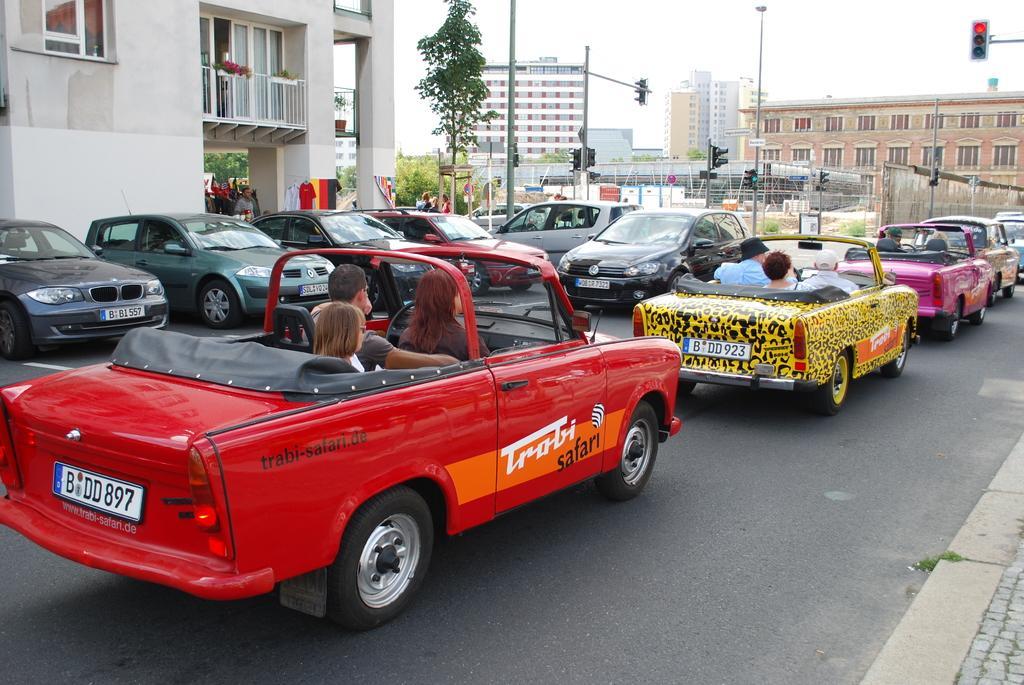Please provide a concise description of this image. In this image we can see many buildings. In one white building one person is standing and some cars are parked in front of that building. Some shirts are there. One big tree is there, small pot is there in the balcony and some bushes is there. Two flags are there. Two persons are standing near the sign board and In road so much of traffic. Signal lights are there, so many cars are waiting for that green signal to move. On that road in pink car there are 2 persons, yellow car 3 persons are there , in red car one man, one woman and one child is sitting in that car. 